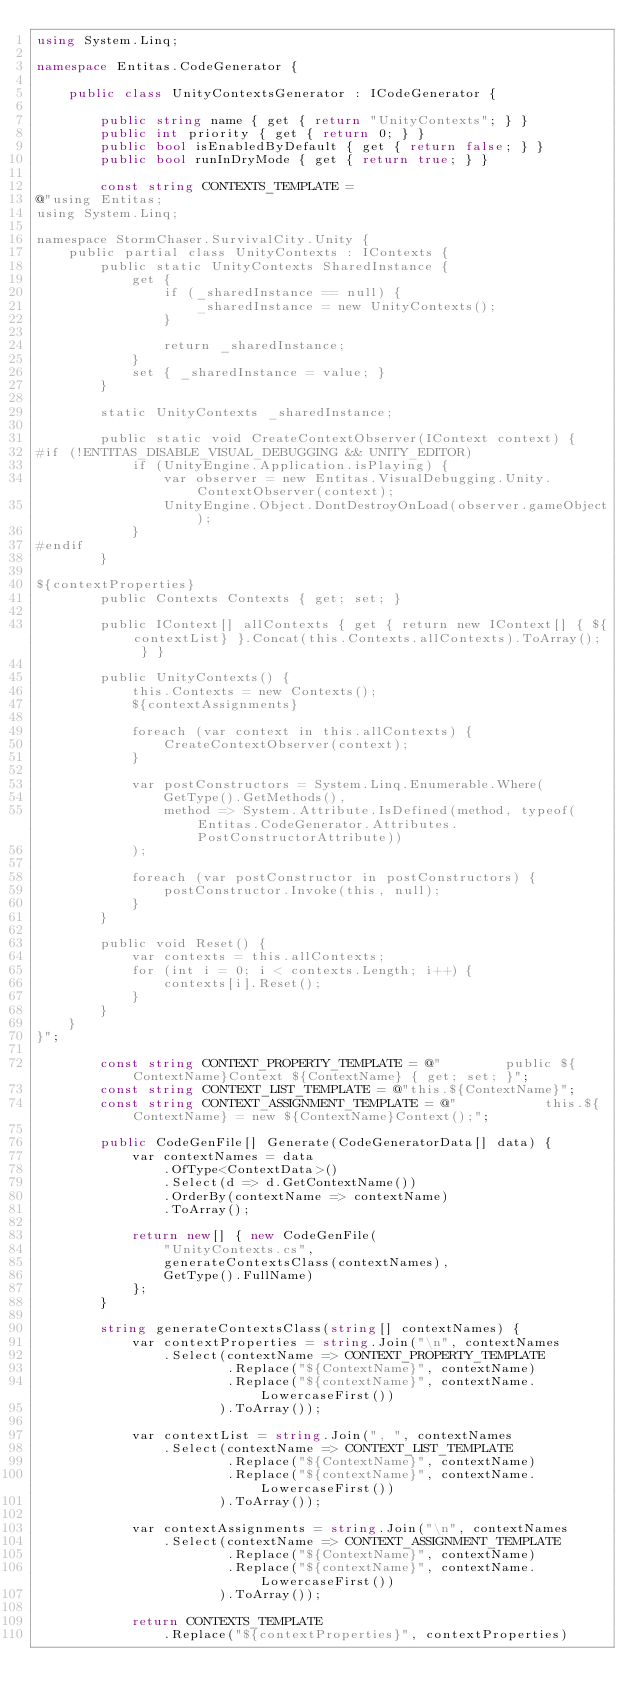<code> <loc_0><loc_0><loc_500><loc_500><_C#_>using System.Linq;

namespace Entitas.CodeGenerator {

    public class UnityContextsGenerator : ICodeGenerator {

        public string name { get { return "UnityContexts"; } }
        public int priority { get { return 0; } }
        public bool isEnabledByDefault { get { return false; } }
        public bool runInDryMode { get { return true; } }

        const string CONTEXTS_TEMPLATE =
@"using Entitas;
using System.Linq;

namespace StormChaser.SurvivalCity.Unity {
    public partial class UnityContexts : IContexts {
        public static UnityContexts SharedInstance {
            get {
                if (_sharedInstance == null) {
                    _sharedInstance = new UnityContexts();
                }

                return _sharedInstance;
            }
            set { _sharedInstance = value; }
        }

        static UnityContexts _sharedInstance;

        public static void CreateContextObserver(IContext context) {
#if (!ENTITAS_DISABLE_VISUAL_DEBUGGING && UNITY_EDITOR)
            if (UnityEngine.Application.isPlaying) {
                var observer = new Entitas.VisualDebugging.Unity.ContextObserver(context);
                UnityEngine.Object.DontDestroyOnLoad(observer.gameObject);
            }
#endif
        }

${contextProperties}
        public Contexts Contexts { get; set; }

        public IContext[] allContexts { get { return new IContext[] { ${contextList} }.Concat(this.Contexts.allContexts).ToArray(); } }

        public UnityContexts() {
            this.Contexts = new Contexts();
            ${contextAssignments}

            foreach (var context in this.allContexts) {
                CreateContextObserver(context);
            }

            var postConstructors = System.Linq.Enumerable.Where(
                GetType().GetMethods(),
                method => System.Attribute.IsDefined(method, typeof(Entitas.CodeGenerator.Attributes.PostConstructorAttribute))
            );

            foreach (var postConstructor in postConstructors) {
                postConstructor.Invoke(this, null);
            }
        }

        public void Reset() {
            var contexts = this.allContexts;
            for (int i = 0; i < contexts.Length; i++) {
                contexts[i].Reset();
            }
        }
    }
}";

        const string CONTEXT_PROPERTY_TEMPLATE = @"        public ${ContextName}Context ${ContextName} { get; set; }";
        const string CONTEXT_LIST_TEMPLATE = @"this.${ContextName}";
        const string CONTEXT_ASSIGNMENT_TEMPLATE = @"           this.${ContextName} = new ${ContextName}Context();";

        public CodeGenFile[] Generate(CodeGeneratorData[] data) {
            var contextNames = data
                .OfType<ContextData>()
                .Select(d => d.GetContextName())
                .OrderBy(contextName => contextName)
                .ToArray();

            return new[] { new CodeGenFile(
                "UnityContexts.cs",
                generateContextsClass(contextNames),
                GetType().FullName)
            };
        }

        string generateContextsClass(string[] contextNames) {
            var contextProperties = string.Join("\n", contextNames
                .Select(contextName => CONTEXT_PROPERTY_TEMPLATE
                        .Replace("${ContextName}", contextName)
                        .Replace("${contextName}", contextName.LowercaseFirst())
                       ).ToArray());

            var contextList = string.Join(", ", contextNames
                .Select(contextName => CONTEXT_LIST_TEMPLATE
                        .Replace("${ContextName}", contextName)
                        .Replace("${contextName}", contextName.LowercaseFirst())
                       ).ToArray());

            var contextAssignments = string.Join("\n", contextNames
                .Select(contextName => CONTEXT_ASSIGNMENT_TEMPLATE
                        .Replace("${ContextName}", contextName)
                        .Replace("${contextName}", contextName.LowercaseFirst())
                       ).ToArray());

            return CONTEXTS_TEMPLATE
                .Replace("${contextProperties}", contextProperties)</code> 